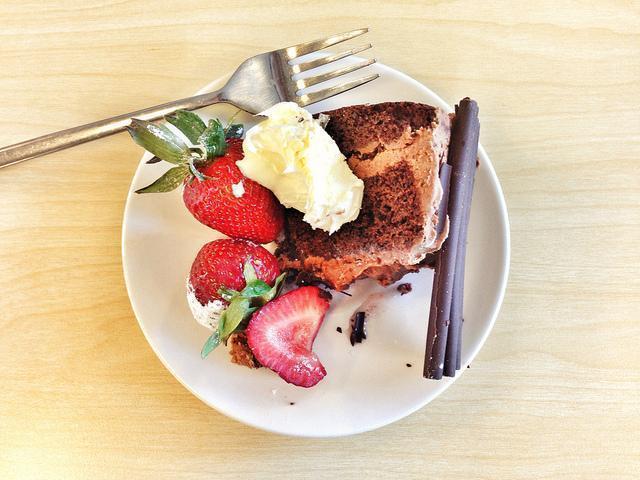What kind of fruit is there a serving of to the side of the cake?
Pick the correct solution from the four options below to address the question.
Options: Raspberry, strawbery, pineapple, grapefruit. Strawbery. 